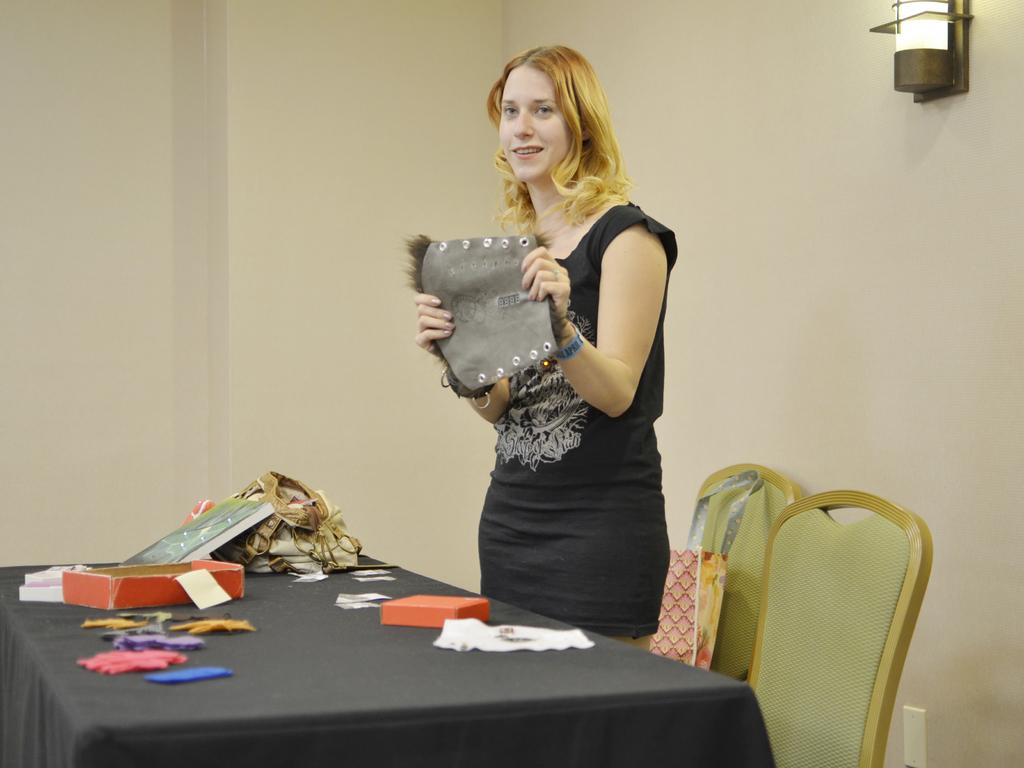Who is present in the image? There is a woman in the image. What is the woman holding in her hands? The woman is holding an object in her hands. What piece of furniture can be seen in the image? There is a table in the image. Are there any other items of furniture in the image? Yes, there are chairs in the image. What else can be seen on the table besides the woman's object? There are other objects on the table. What type of stem can be seen growing from the woman's head in the image? There is no stem growing from the woman's head in the image. What message of peace is being conveyed by the woman in the image? The image does not convey any specific message of peace; it simply shows a woman holding an object. 